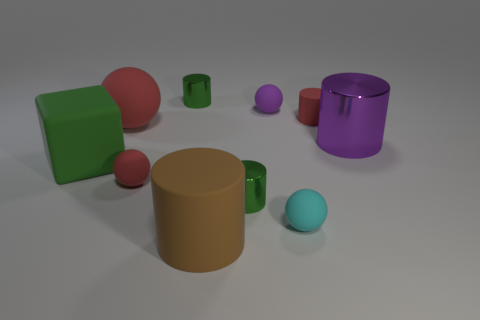Subtract all large purple metal cylinders. How many cylinders are left? 4 Subtract 1 spheres. How many spheres are left? 3 Subtract all brown cylinders. How many cylinders are left? 4 Subtract all blue cylinders. Subtract all yellow balls. How many cylinders are left? 5 Subtract all cubes. How many objects are left? 9 Subtract 0 blue blocks. How many objects are left? 10 Subtract all small yellow cubes. Subtract all large red rubber objects. How many objects are left? 9 Add 7 big red matte objects. How many big red matte objects are left? 8 Add 9 tiny purple matte spheres. How many tiny purple matte spheres exist? 10 